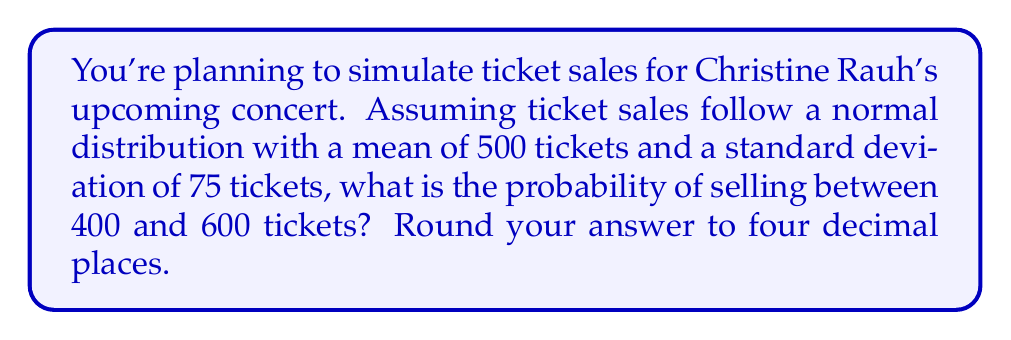Can you solve this math problem? To solve this problem, we'll use the properties of the normal distribution and the concept of z-scores.

Step 1: Identify the given information
- Mean (μ) = 500 tickets
- Standard deviation (σ) = 75 tickets
- Lower bound = 400 tickets
- Upper bound = 600 tickets

Step 2: Calculate the z-scores for the lower and upper bounds
For the lower bound:
$z_1 = \frac{x_1 - \mu}{\sigma} = \frac{400 - 500}{75} = -1.33$

For the upper bound:
$z_2 = \frac{x_2 - \mu}{\sigma} = \frac{600 - 500}{75} = 1.33$

Step 3: Use the standard normal distribution table or a calculator to find the area under the curve between these z-scores

The probability is equal to the area under the standard normal curve between $z_1$ and $z_2$.

$P(-1.33 < Z < 1.33) = P(Z < 1.33) - P(Z < -1.33)$

Using a standard normal table or calculator:
$P(Z < 1.33) = 0.9082$
$P(Z < -1.33) = 0.0918$

Therefore, $P(-1.33 < Z < 1.33) = 0.9082 - 0.0918 = 0.8164$

Step 4: Round the result to four decimal places

0.8164 rounded to four decimal places is 0.8164.
Answer: 0.8164 